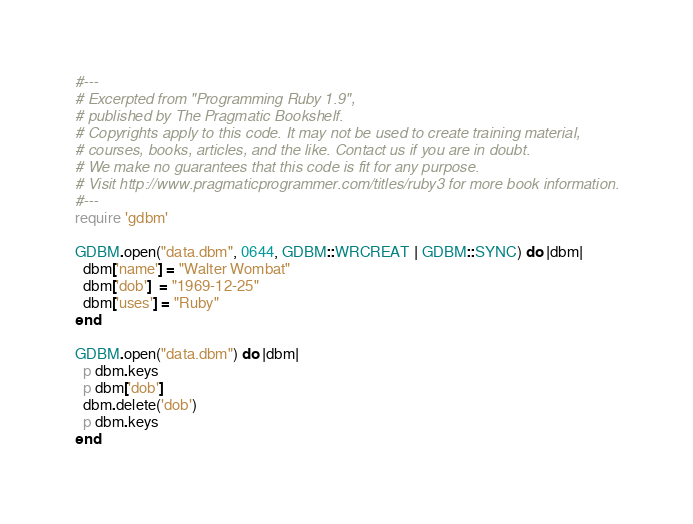<code> <loc_0><loc_0><loc_500><loc_500><_Ruby_>#---
# Excerpted from "Programming Ruby 1.9",
# published by The Pragmatic Bookshelf.
# Copyrights apply to this code. It may not be used to create training material, 
# courses, books, articles, and the like. Contact us if you are in doubt.
# We make no guarantees that this code is fit for any purpose. 
# Visit http://www.pragmaticprogrammer.com/titles/ruby3 for more book information.
#---
require 'gdbm'

GDBM.open("data.dbm", 0644, GDBM::WRCREAT | GDBM::SYNC) do |dbm|
  dbm['name'] = "Walter Wombat"
  dbm['dob']  = "1969-12-25"
  dbm['uses'] = "Ruby"
end

GDBM.open("data.dbm") do |dbm|
  p dbm.keys
  p dbm['dob']
  dbm.delete('dob')
  p dbm.keys
end
</code> 